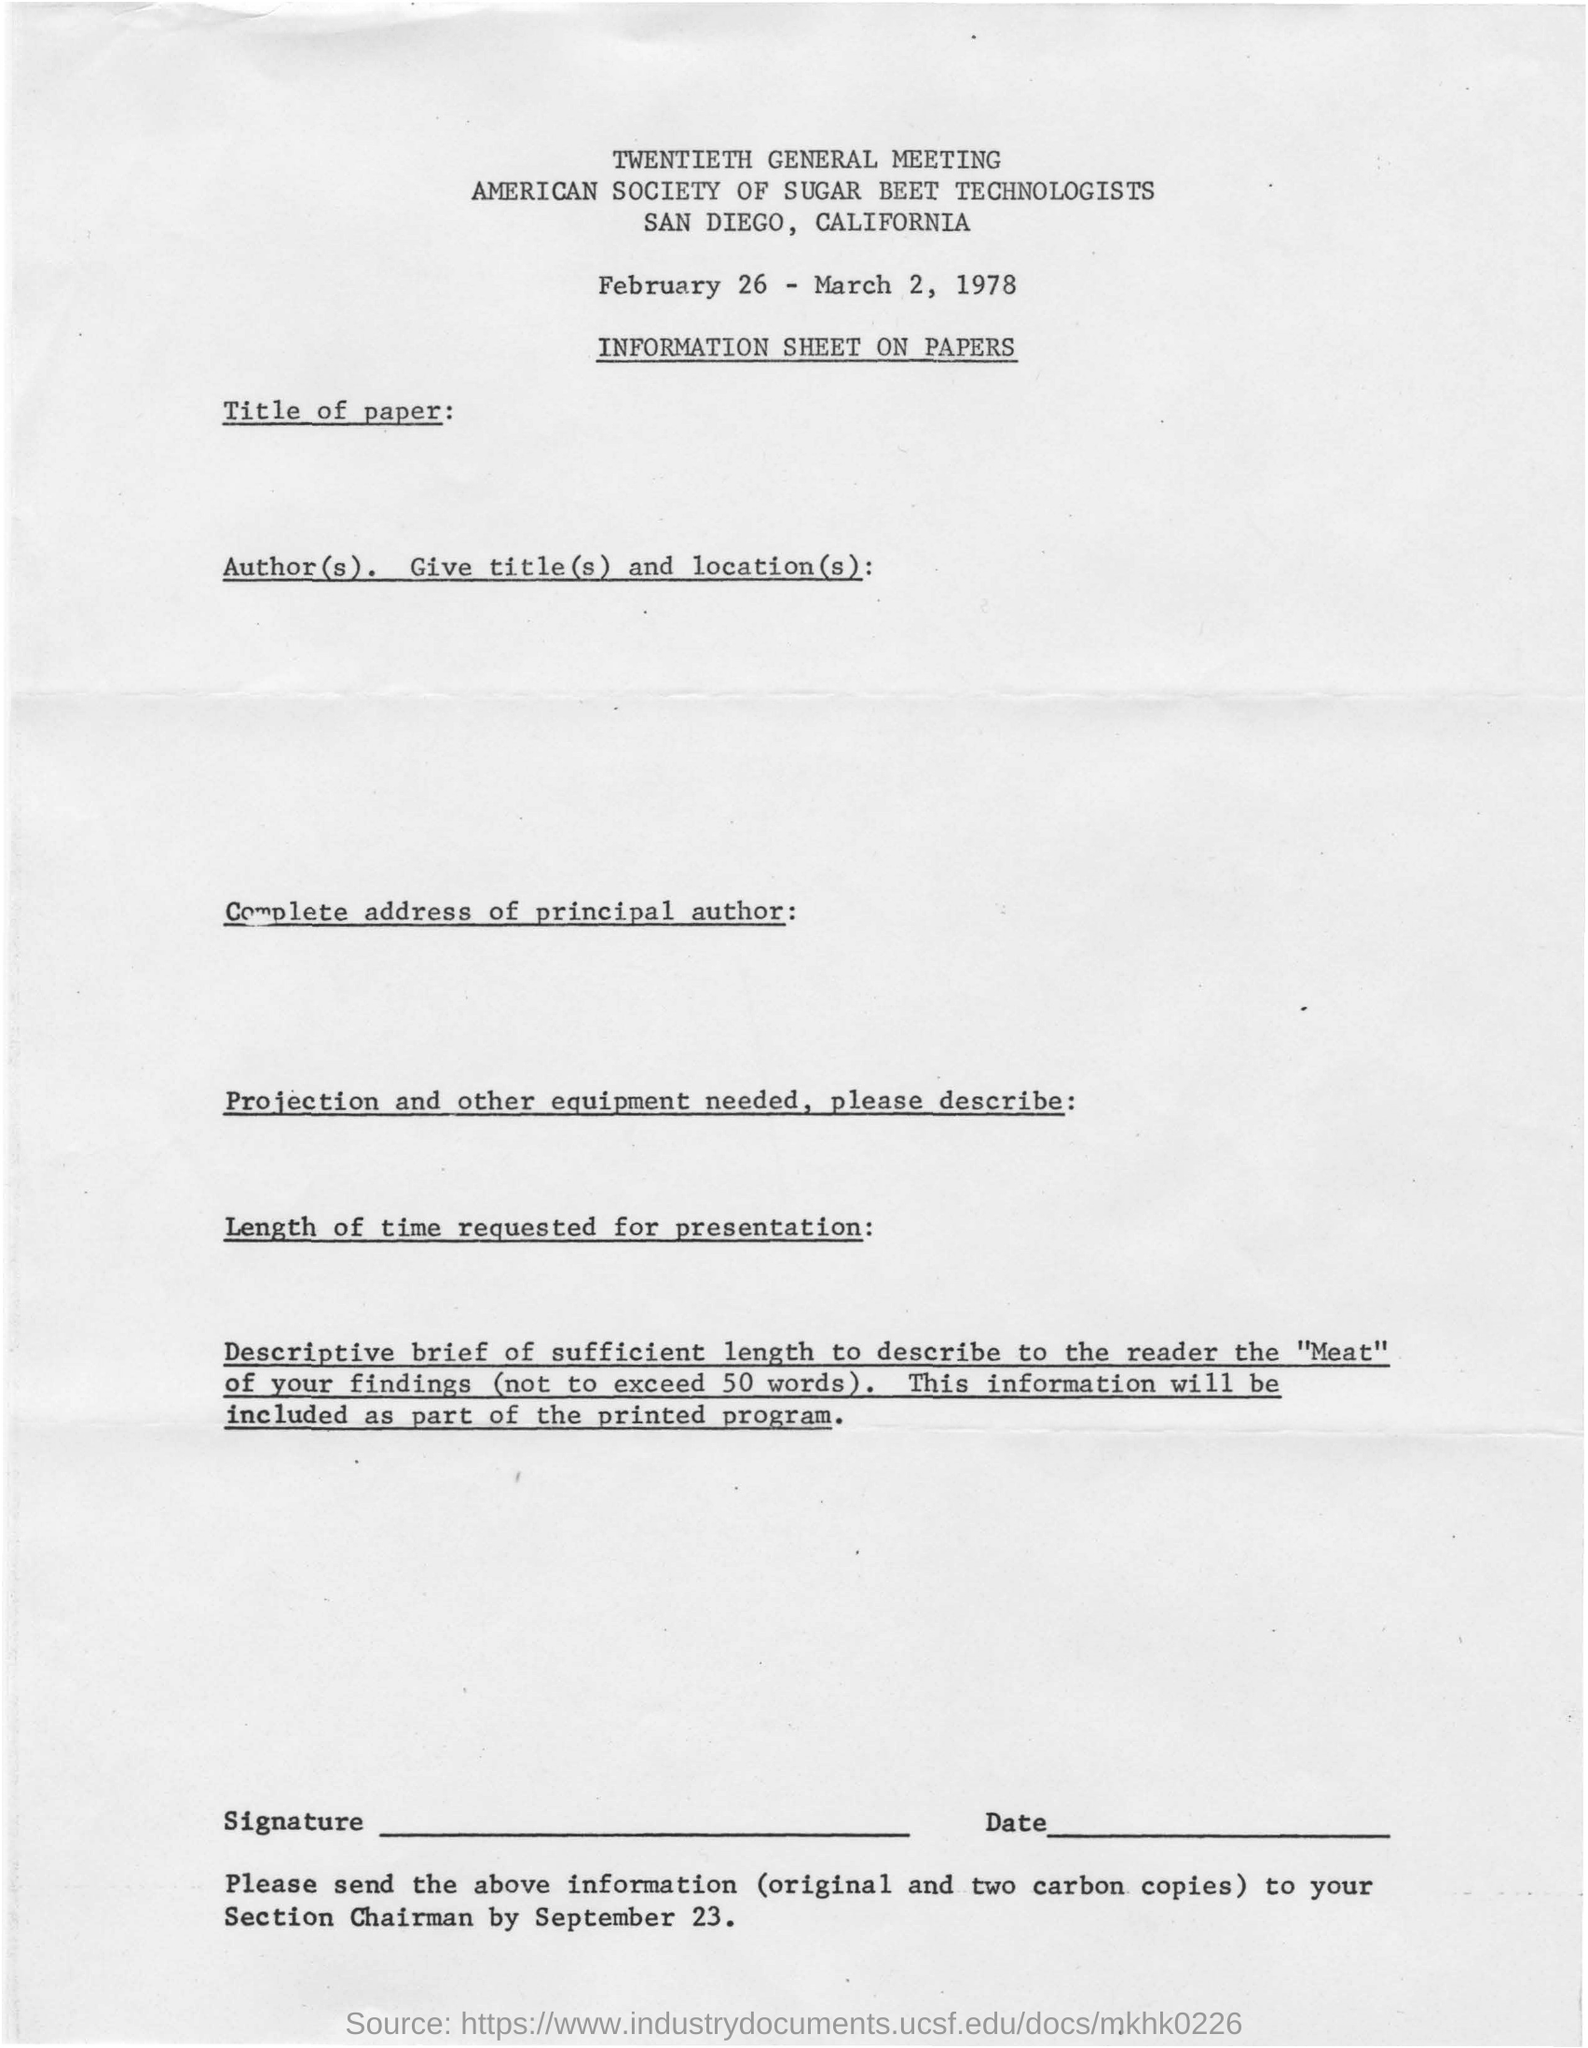Identify some key points in this picture. The date mentioned in the document is February 26 to March 2, 1978. The American Society of Sugar Beet Technologists has its address located in San Diego, California. 